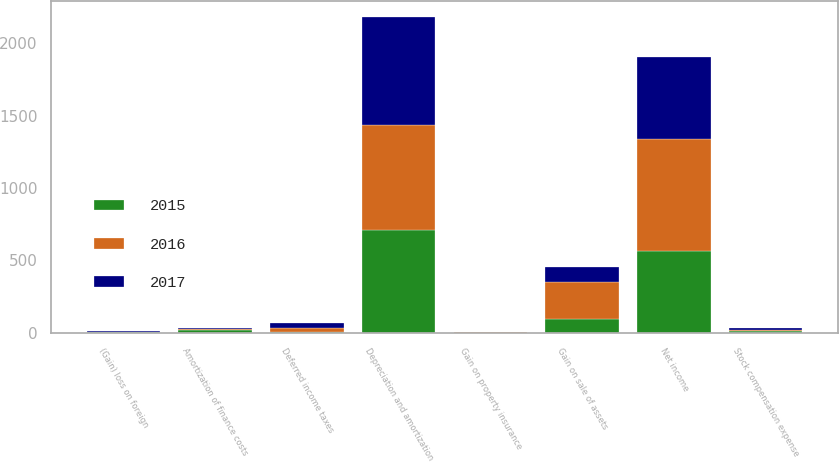<chart> <loc_0><loc_0><loc_500><loc_500><stacked_bar_chart><ecel><fcel>Net income<fcel>Depreciation and amortization<fcel>Amortization of finance costs<fcel>Stock compensation expense<fcel>Deferred income taxes<fcel>Gain on sale of assets<fcel>(Gain) loss on foreign<fcel>Gain on property insurance<nl><fcel>2017<fcel>571<fcel>751<fcel>7<fcel>11<fcel>38<fcel>108<fcel>2<fcel>1<nl><fcel>2016<fcel>771<fcel>724<fcel>7<fcel>12<fcel>27<fcel>253<fcel>4<fcel>1<nl><fcel>2015<fcel>565<fcel>708<fcel>21<fcel>11<fcel>5<fcel>95<fcel>5<fcel>2<nl></chart> 